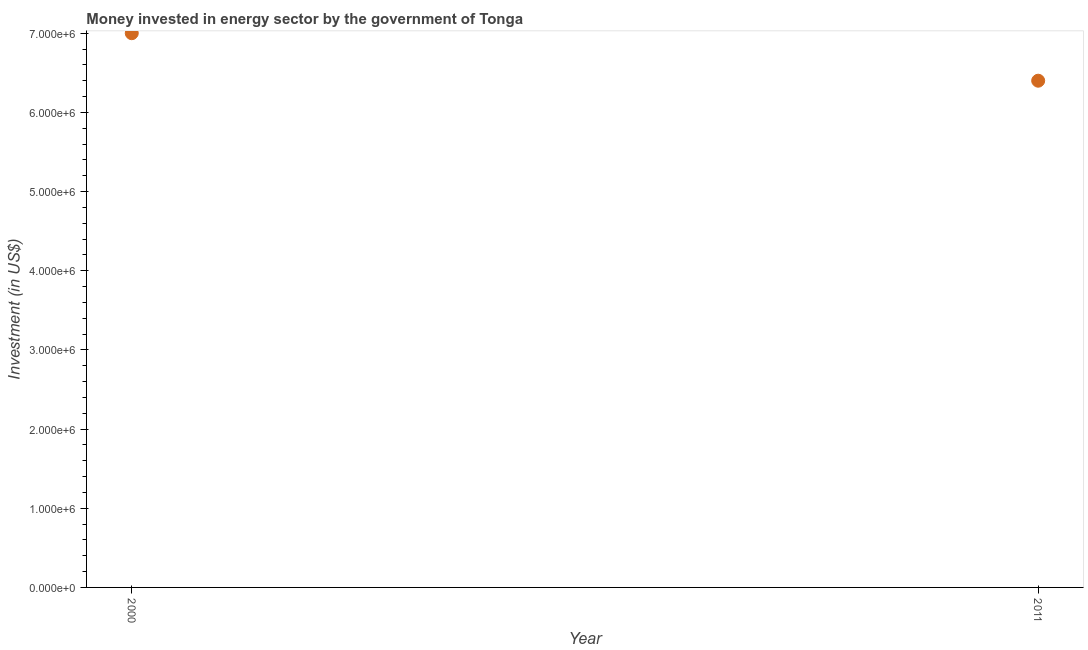What is the investment in energy in 2000?
Your response must be concise. 7.00e+06. Across all years, what is the maximum investment in energy?
Your response must be concise. 7.00e+06. Across all years, what is the minimum investment in energy?
Ensure brevity in your answer.  6.40e+06. In which year was the investment in energy minimum?
Your response must be concise. 2011. What is the sum of the investment in energy?
Your answer should be very brief. 1.34e+07. What is the difference between the investment in energy in 2000 and 2011?
Give a very brief answer. 6.00e+05. What is the average investment in energy per year?
Keep it short and to the point. 6.70e+06. What is the median investment in energy?
Provide a short and direct response. 6.70e+06. In how many years, is the investment in energy greater than 5000000 US$?
Your answer should be very brief. 2. Do a majority of the years between 2000 and 2011 (inclusive) have investment in energy greater than 5400000 US$?
Make the answer very short. Yes. What is the ratio of the investment in energy in 2000 to that in 2011?
Make the answer very short. 1.09. Is the investment in energy in 2000 less than that in 2011?
Offer a very short reply. No. In how many years, is the investment in energy greater than the average investment in energy taken over all years?
Give a very brief answer. 1. Does the investment in energy monotonically increase over the years?
Provide a short and direct response. No. How many years are there in the graph?
Keep it short and to the point. 2. What is the title of the graph?
Provide a short and direct response. Money invested in energy sector by the government of Tonga. What is the label or title of the Y-axis?
Provide a succinct answer. Investment (in US$). What is the Investment (in US$) in 2000?
Provide a succinct answer. 7.00e+06. What is the Investment (in US$) in 2011?
Your response must be concise. 6.40e+06. What is the difference between the Investment (in US$) in 2000 and 2011?
Your answer should be compact. 6.00e+05. What is the ratio of the Investment (in US$) in 2000 to that in 2011?
Your answer should be very brief. 1.09. 